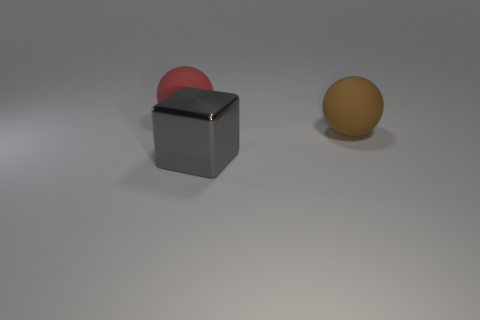What colors are present in the objects within the image? The image features objects with several colors. There is a gray cube, a sphere that has a mix of red and pink colors, and another sphere that appears to be yellowish-orange. 